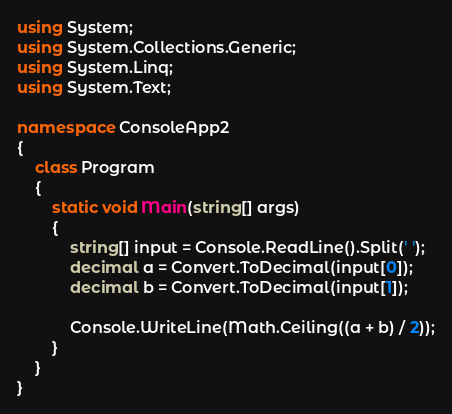Convert code to text. <code><loc_0><loc_0><loc_500><loc_500><_C#_>using System;
using System.Collections.Generic;
using System.Linq;
using System.Text;

namespace ConsoleApp2
{
    class Program
    {
        static void Main(string[] args)
        {
            string[] input = Console.ReadLine().Split(' ');
            decimal a = Convert.ToDecimal(input[0]);
            decimal b = Convert.ToDecimal(input[1]);

            Console.WriteLine(Math.Ceiling((a + b) / 2));
        }
    }
}
</code> 